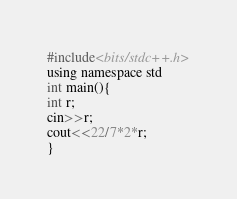<code> <loc_0><loc_0><loc_500><loc_500><_C_>#include<bits/stdc++.h>
using namespace std
int main(){
int r;
cin>>r;
cout<<22/7*2*r;
}</code> 